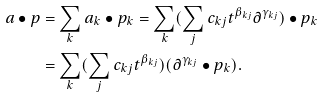Convert formula to latex. <formula><loc_0><loc_0><loc_500><loc_500>a \bullet p & = \sum _ { k } a _ { k } \bullet p _ { k } = \sum _ { k } ( \sum _ { j } c _ { k j } t ^ { \beta _ { k j } } \partial ^ { \gamma _ { k j } } ) \bullet p _ { k } \\ & = \sum _ { k } ( \sum _ { j } c _ { k j } t ^ { \beta _ { k j } } ) ( \partial ^ { \gamma _ { k j } } \bullet p _ { k } ) .</formula> 